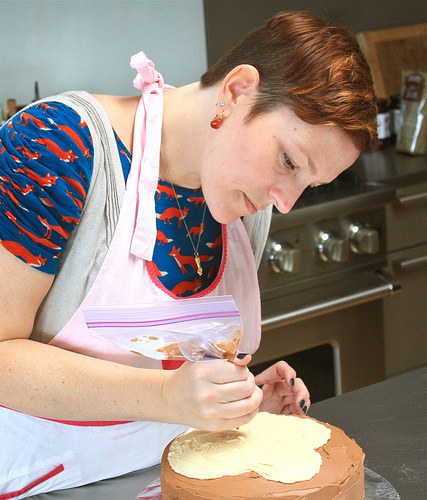<image>
Can you confirm if the cake is next to the counter? No. The cake is not positioned next to the counter. They are located in different areas of the scene. 